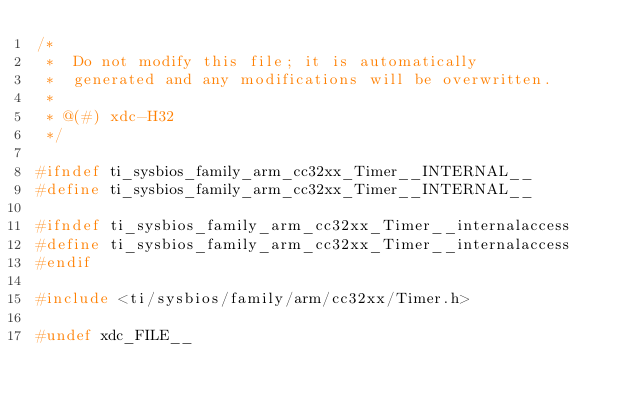Convert code to text. <code><loc_0><loc_0><loc_500><loc_500><_C_>/*
 *  Do not modify this file; it is automatically 
 *  generated and any modifications will be overwritten.
 *
 * @(#) xdc-H32
 */

#ifndef ti_sysbios_family_arm_cc32xx_Timer__INTERNAL__
#define ti_sysbios_family_arm_cc32xx_Timer__INTERNAL__

#ifndef ti_sysbios_family_arm_cc32xx_Timer__internalaccess
#define ti_sysbios_family_arm_cc32xx_Timer__internalaccess
#endif

#include <ti/sysbios/family/arm/cc32xx/Timer.h>

#undef xdc_FILE__</code> 